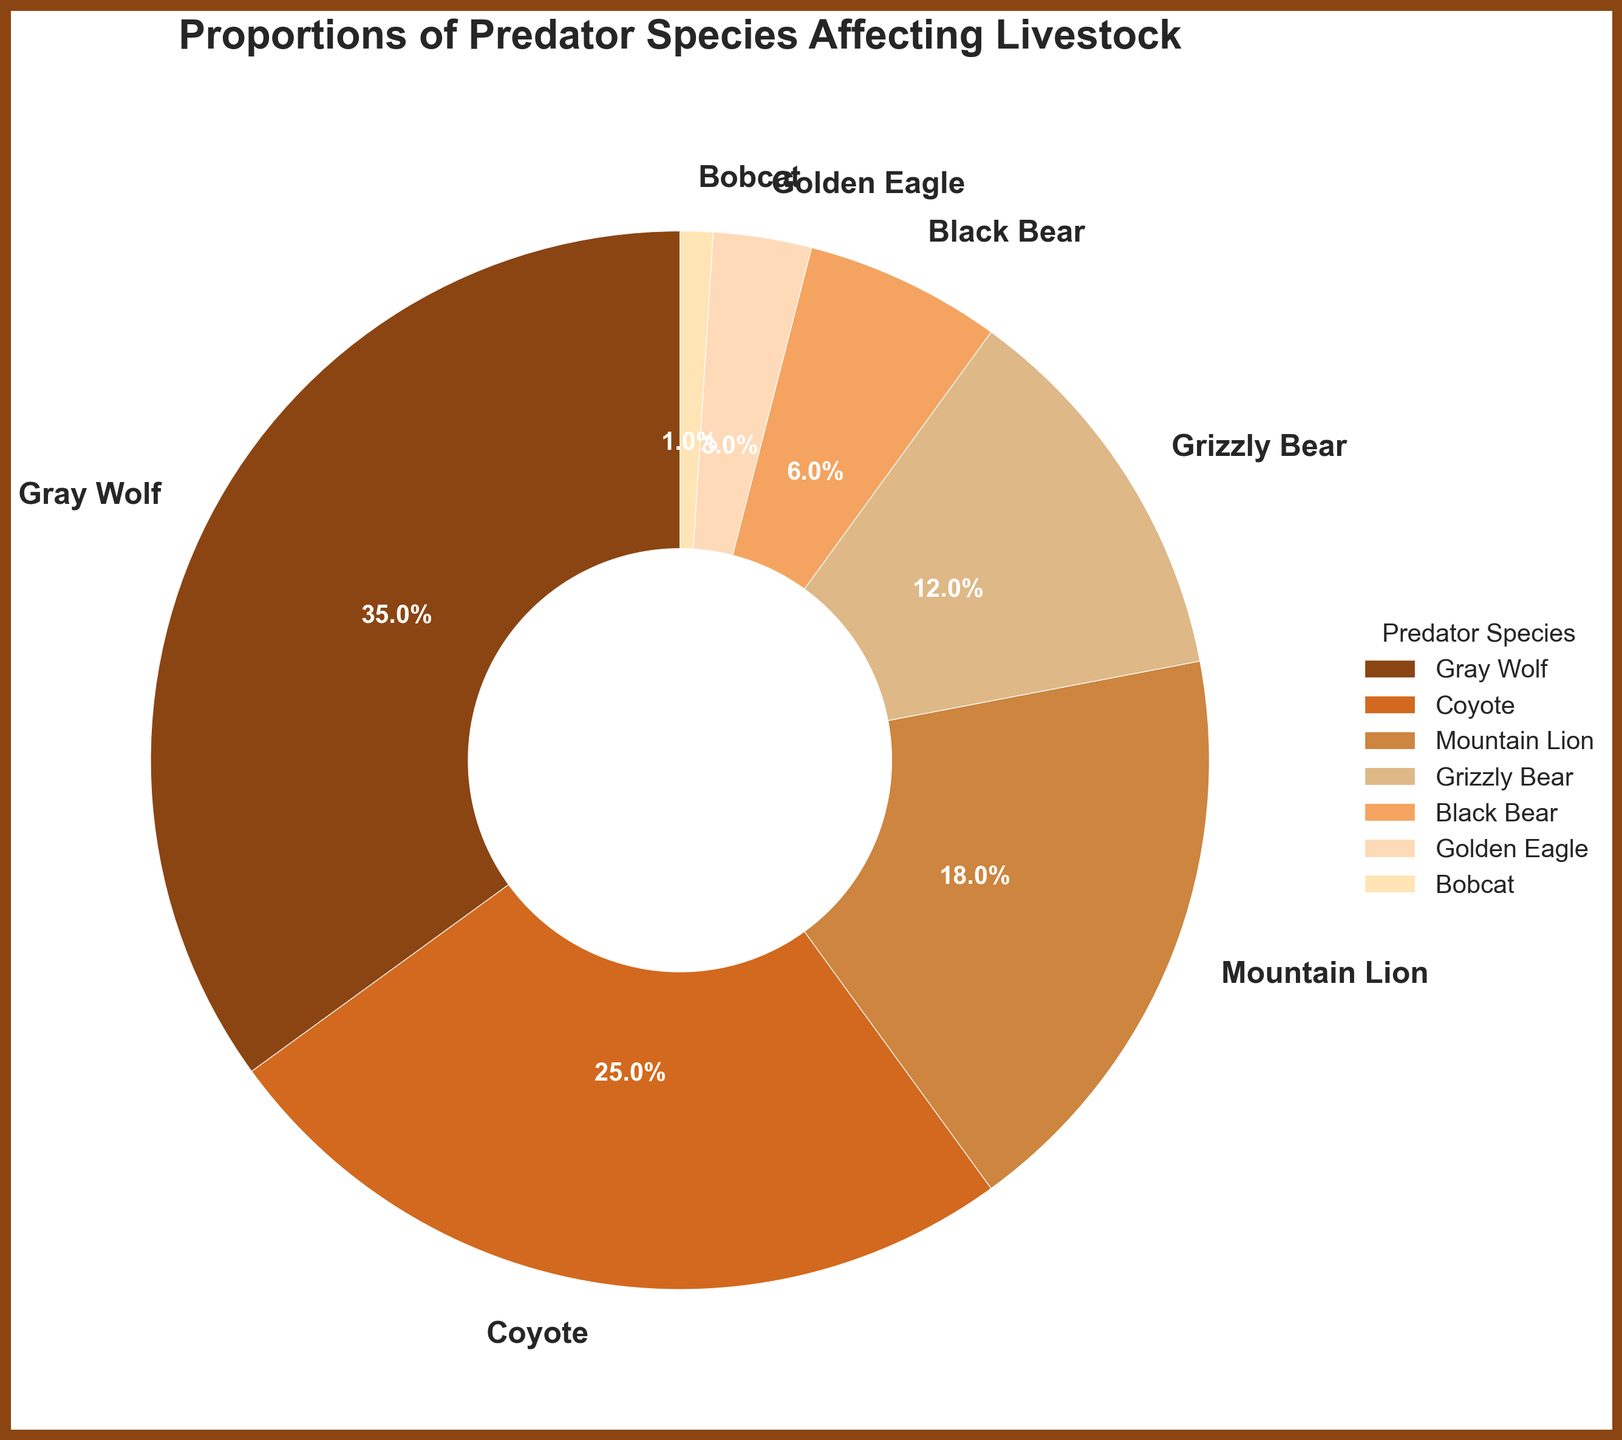What's the predator species with the highest percentage affecting livestock? According to the chart, the predator species with the highest percentage labeled on the pie chart is Gray Wolf.
Answer: Gray Wolf Which two predator species combined have an impact percentage closest to 50%? To find this, look at the percentages and find a combination that adds up to around 50%. The combination of Gray Wolf (35%) and Coyote (25%) exceeds 50%, but Gray Wolf (35%) and Mountain Lion (18%) total 53%, closer than any other combination.
Answer: Gray Wolf and Mountain Lion What's the difference in the impact percentage between Grizzly Bear and Black Bear? Subtract the percentage of Black Bear from the percentage of Grizzly Bear: 12% (Grizzly Bear) - 6% (Black Bear) = 6%.
Answer: 6% Which predator species has a percentage closest to 20%? From the chart, the closest percentage to 20% is the Mountain Lion, which has an 18% share.
Answer: Mountain Lion What's the combined impact percentage of the two least significant species? Adding the percentages of the two least significant species, Bobcat (1%) and Golden Eagle (3%): 1% + 3% = 4%.
Answer: 4% How does the proportion of Coyotes compare to Gray Wolves? The percentage of Coyotes (25%) is less than the percentage of Gray Wolves (35%), because 25% < 35%.
Answer: Coyotes have a smaller proportion Which species has more impact, Grizzly Bear or Mountain Lion, and by how much? Comparing their percentages: Mountain Lion (18%) - Grizzly Bear (12%) = 6%. Mountain Lion has a 6% greater impact.
Answer: Mountain Lion by 6% If you combine the impacts of all bear species, what is the total percentage? Adding the percentages of Grizzly Bear (12%) and Black Bear (6%): 12% + 6% = 18%.
Answer: 18% What's the sum of impacts from Gray Wolf, Coyote, and Mountain Lion? Adding their percentages: 35% (Gray Wolf) + 25% (Coyote) + 18% (Mountain Lion) = 78%.
Answer: 78% Which predator species is represented by the lightest color in the chart's legend? Looking at the chart and legend, the lightest color corresponds to Bobcat, which has the smallest percentage (1%).
Answer: Bobcat 